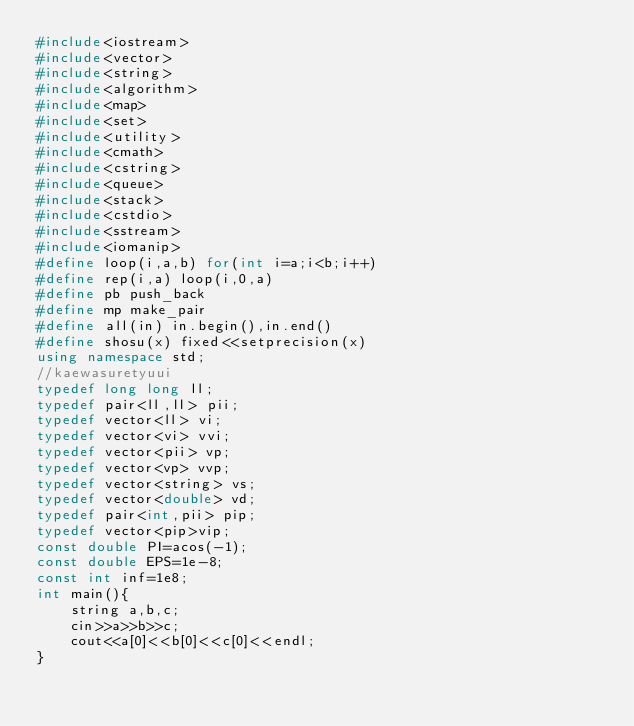<code> <loc_0><loc_0><loc_500><loc_500><_C++_>#include<iostream>
#include<vector>
#include<string>
#include<algorithm>	
#include<map>
#include<set>
#include<utility>
#include<cmath>
#include<cstring>
#include<queue>
#include<stack>
#include<cstdio>
#include<sstream>
#include<iomanip>
#define loop(i,a,b) for(int i=a;i<b;i++) 
#define rep(i,a) loop(i,0,a)
#define pb push_back
#define mp make_pair
#define all(in) in.begin(),in.end()
#define shosu(x) fixed<<setprecision(x)
using namespace std;
//kaewasuretyuui
typedef long long ll;
typedef pair<ll,ll> pii;
typedef vector<ll> vi;
typedef vector<vi> vvi;
typedef vector<pii> vp;
typedef vector<vp> vvp;
typedef vector<string> vs;
typedef vector<double> vd;
typedef pair<int,pii> pip;
typedef vector<pip>vip;
const double PI=acos(-1);
const double EPS=1e-8;
const int inf=1e8;
int main(){
	string a,b,c;
	cin>>a>>b>>c;
	cout<<a[0]<<b[0]<<c[0]<<endl;
}








</code> 